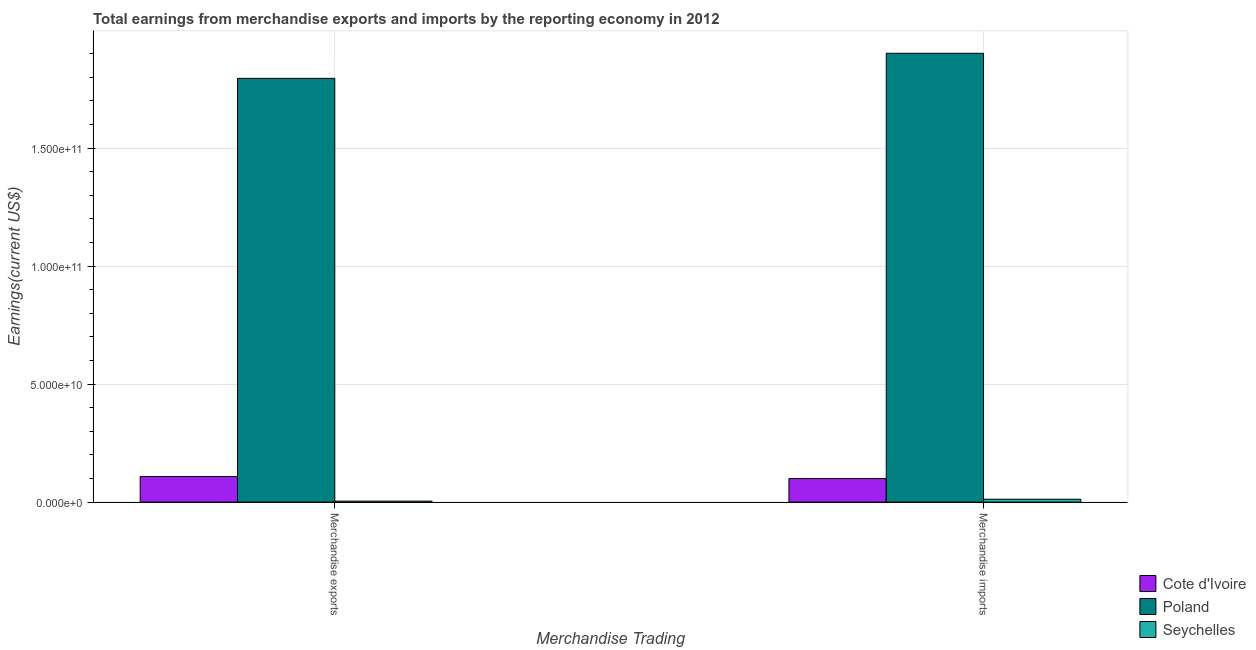How many groups of bars are there?
Your response must be concise. 2. Are the number of bars per tick equal to the number of legend labels?
Your answer should be very brief. Yes. How many bars are there on the 1st tick from the right?
Your answer should be very brief. 3. What is the earnings from merchandise exports in Cote d'Ivoire?
Offer a terse response. 1.09e+1. Across all countries, what is the maximum earnings from merchandise exports?
Make the answer very short. 1.80e+11. Across all countries, what is the minimum earnings from merchandise exports?
Your answer should be compact. 4.23e+08. In which country was the earnings from merchandise imports minimum?
Make the answer very short. Seychelles. What is the total earnings from merchandise imports in the graph?
Your answer should be compact. 2.01e+11. What is the difference between the earnings from merchandise imports in Poland and that in Seychelles?
Give a very brief answer. 1.89e+11. What is the difference between the earnings from merchandise imports in Seychelles and the earnings from merchandise exports in Poland?
Ensure brevity in your answer.  -1.78e+11. What is the average earnings from merchandise exports per country?
Offer a terse response. 6.36e+1. What is the difference between the earnings from merchandise imports and earnings from merchandise exports in Seychelles?
Your answer should be compact. 8.01e+08. In how many countries, is the earnings from merchandise exports greater than 140000000000 US$?
Your response must be concise. 1. What is the ratio of the earnings from merchandise exports in Seychelles to that in Cote d'Ivoire?
Offer a terse response. 0.04. Is the earnings from merchandise exports in Seychelles less than that in Poland?
Your response must be concise. Yes. What does the 2nd bar from the left in Merchandise exports represents?
Give a very brief answer. Poland. What does the 2nd bar from the right in Merchandise exports represents?
Keep it short and to the point. Poland. How many bars are there?
Your response must be concise. 6. Does the graph contain grids?
Your answer should be compact. Yes. How are the legend labels stacked?
Provide a succinct answer. Vertical. What is the title of the graph?
Provide a short and direct response. Total earnings from merchandise exports and imports by the reporting economy in 2012. Does "Denmark" appear as one of the legend labels in the graph?
Ensure brevity in your answer.  No. What is the label or title of the X-axis?
Ensure brevity in your answer.  Merchandise Trading. What is the label or title of the Y-axis?
Your answer should be compact. Earnings(current US$). What is the Earnings(current US$) in Cote d'Ivoire in Merchandise exports?
Make the answer very short. 1.09e+1. What is the Earnings(current US$) in Poland in Merchandise exports?
Your answer should be very brief. 1.80e+11. What is the Earnings(current US$) of Seychelles in Merchandise exports?
Keep it short and to the point. 4.23e+08. What is the Earnings(current US$) of Cote d'Ivoire in Merchandise imports?
Make the answer very short. 9.97e+09. What is the Earnings(current US$) in Poland in Merchandise imports?
Give a very brief answer. 1.90e+11. What is the Earnings(current US$) in Seychelles in Merchandise imports?
Offer a very short reply. 1.22e+09. Across all Merchandise Trading, what is the maximum Earnings(current US$) of Cote d'Ivoire?
Provide a succinct answer. 1.09e+1. Across all Merchandise Trading, what is the maximum Earnings(current US$) in Poland?
Offer a very short reply. 1.90e+11. Across all Merchandise Trading, what is the maximum Earnings(current US$) of Seychelles?
Offer a terse response. 1.22e+09. Across all Merchandise Trading, what is the minimum Earnings(current US$) in Cote d'Ivoire?
Your answer should be very brief. 9.97e+09. Across all Merchandise Trading, what is the minimum Earnings(current US$) in Poland?
Provide a succinct answer. 1.80e+11. Across all Merchandise Trading, what is the minimum Earnings(current US$) in Seychelles?
Provide a short and direct response. 4.23e+08. What is the total Earnings(current US$) of Cote d'Ivoire in the graph?
Offer a very short reply. 2.08e+1. What is the total Earnings(current US$) of Poland in the graph?
Give a very brief answer. 3.70e+11. What is the total Earnings(current US$) of Seychelles in the graph?
Ensure brevity in your answer.  1.65e+09. What is the difference between the Earnings(current US$) in Cote d'Ivoire in Merchandise exports and that in Merchandise imports?
Provide a succinct answer. 8.92e+08. What is the difference between the Earnings(current US$) in Poland in Merchandise exports and that in Merchandise imports?
Your answer should be very brief. -1.06e+1. What is the difference between the Earnings(current US$) of Seychelles in Merchandise exports and that in Merchandise imports?
Make the answer very short. -8.01e+08. What is the difference between the Earnings(current US$) in Cote d'Ivoire in Merchandise exports and the Earnings(current US$) in Poland in Merchandise imports?
Offer a terse response. -1.79e+11. What is the difference between the Earnings(current US$) of Cote d'Ivoire in Merchandise exports and the Earnings(current US$) of Seychelles in Merchandise imports?
Offer a terse response. 9.64e+09. What is the difference between the Earnings(current US$) of Poland in Merchandise exports and the Earnings(current US$) of Seychelles in Merchandise imports?
Offer a very short reply. 1.78e+11. What is the average Earnings(current US$) of Cote d'Ivoire per Merchandise Trading?
Offer a terse response. 1.04e+1. What is the average Earnings(current US$) of Poland per Merchandise Trading?
Offer a terse response. 1.85e+11. What is the average Earnings(current US$) of Seychelles per Merchandise Trading?
Offer a very short reply. 8.24e+08. What is the difference between the Earnings(current US$) in Cote d'Ivoire and Earnings(current US$) in Poland in Merchandise exports?
Keep it short and to the point. -1.69e+11. What is the difference between the Earnings(current US$) of Cote d'Ivoire and Earnings(current US$) of Seychelles in Merchandise exports?
Offer a terse response. 1.04e+1. What is the difference between the Earnings(current US$) of Poland and Earnings(current US$) of Seychelles in Merchandise exports?
Ensure brevity in your answer.  1.79e+11. What is the difference between the Earnings(current US$) in Cote d'Ivoire and Earnings(current US$) in Poland in Merchandise imports?
Give a very brief answer. -1.80e+11. What is the difference between the Earnings(current US$) of Cote d'Ivoire and Earnings(current US$) of Seychelles in Merchandise imports?
Provide a short and direct response. 8.75e+09. What is the difference between the Earnings(current US$) in Poland and Earnings(current US$) in Seychelles in Merchandise imports?
Provide a short and direct response. 1.89e+11. What is the ratio of the Earnings(current US$) in Cote d'Ivoire in Merchandise exports to that in Merchandise imports?
Your answer should be very brief. 1.09. What is the ratio of the Earnings(current US$) in Poland in Merchandise exports to that in Merchandise imports?
Keep it short and to the point. 0.94. What is the ratio of the Earnings(current US$) of Seychelles in Merchandise exports to that in Merchandise imports?
Offer a very short reply. 0.35. What is the difference between the highest and the second highest Earnings(current US$) of Cote d'Ivoire?
Give a very brief answer. 8.92e+08. What is the difference between the highest and the second highest Earnings(current US$) in Poland?
Make the answer very short. 1.06e+1. What is the difference between the highest and the second highest Earnings(current US$) in Seychelles?
Make the answer very short. 8.01e+08. What is the difference between the highest and the lowest Earnings(current US$) of Cote d'Ivoire?
Your answer should be compact. 8.92e+08. What is the difference between the highest and the lowest Earnings(current US$) of Poland?
Provide a succinct answer. 1.06e+1. What is the difference between the highest and the lowest Earnings(current US$) of Seychelles?
Ensure brevity in your answer.  8.01e+08. 